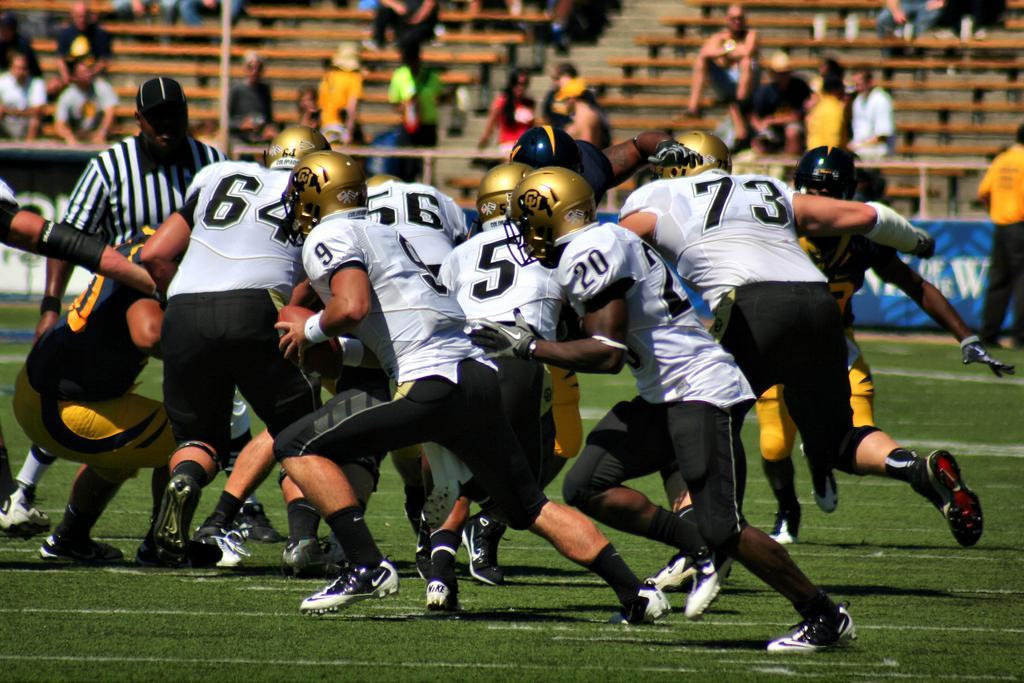In one or two sentences, can you explain what this image depicts? In the center of the image a group of people are there, some of them are wearing helmet, gloves. In the background of the image we can see some persons chairs, stairs are there. At the bottom of the image ground is there. In the middle of the image boards, pole are there. 